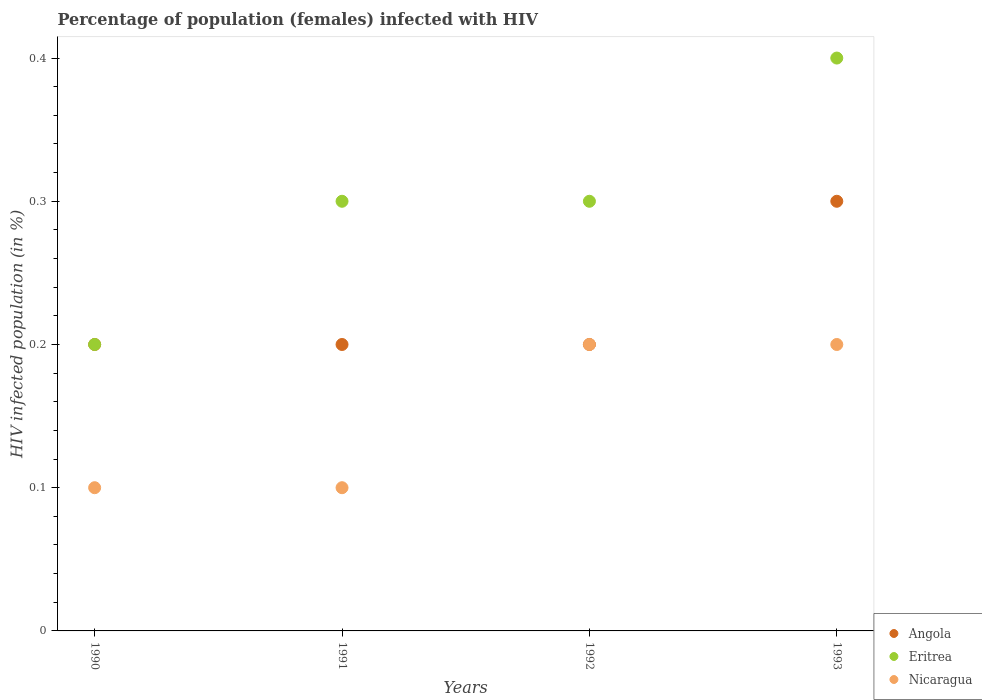How many different coloured dotlines are there?
Make the answer very short. 3. What is the percentage of HIV infected female population in Eritrea in 1991?
Give a very brief answer. 0.3. In which year was the percentage of HIV infected female population in Angola maximum?
Give a very brief answer. 1993. In which year was the percentage of HIV infected female population in Angola minimum?
Keep it short and to the point. 1990. What is the total percentage of HIV infected female population in Nicaragua in the graph?
Offer a terse response. 0.6. What is the difference between the percentage of HIV infected female population in Angola in 1990 and that in 1991?
Make the answer very short. 0. What is the difference between the percentage of HIV infected female population in Angola in 1992 and the percentage of HIV infected female population in Eritrea in 1990?
Ensure brevity in your answer.  0. What is the average percentage of HIV infected female population in Eritrea per year?
Your answer should be compact. 0.3. In the year 1991, what is the difference between the percentage of HIV infected female population in Nicaragua and percentage of HIV infected female population in Eritrea?
Ensure brevity in your answer.  -0.2. Is the difference between the percentage of HIV infected female population in Nicaragua in 1990 and 1991 greater than the difference between the percentage of HIV infected female population in Eritrea in 1990 and 1991?
Provide a succinct answer. Yes. What is the difference between the highest and the second highest percentage of HIV infected female population in Eritrea?
Your response must be concise. 0.1. What is the difference between the highest and the lowest percentage of HIV infected female population in Nicaragua?
Your answer should be very brief. 0.1. Is it the case that in every year, the sum of the percentage of HIV infected female population in Eritrea and percentage of HIV infected female population in Nicaragua  is greater than the percentage of HIV infected female population in Angola?
Offer a terse response. Yes. How many dotlines are there?
Ensure brevity in your answer.  3. What is the difference between two consecutive major ticks on the Y-axis?
Ensure brevity in your answer.  0.1. Are the values on the major ticks of Y-axis written in scientific E-notation?
Ensure brevity in your answer.  No. Does the graph contain grids?
Ensure brevity in your answer.  No. Where does the legend appear in the graph?
Offer a very short reply. Bottom right. How are the legend labels stacked?
Give a very brief answer. Vertical. What is the title of the graph?
Offer a terse response. Percentage of population (females) infected with HIV. Does "Malta" appear as one of the legend labels in the graph?
Make the answer very short. No. What is the label or title of the X-axis?
Give a very brief answer. Years. What is the label or title of the Y-axis?
Provide a succinct answer. HIV infected population (in %). What is the HIV infected population (in %) of Eritrea in 1990?
Ensure brevity in your answer.  0.2. What is the HIV infected population (in %) in Nicaragua in 1990?
Make the answer very short. 0.1. What is the HIV infected population (in %) of Angola in 1991?
Give a very brief answer. 0.2. What is the HIV infected population (in %) in Angola in 1992?
Provide a succinct answer. 0.2. What is the HIV infected population (in %) of Eritrea in 1992?
Your response must be concise. 0.3. What is the HIV infected population (in %) in Nicaragua in 1992?
Give a very brief answer. 0.2. What is the HIV infected population (in %) in Eritrea in 1993?
Offer a terse response. 0.4. What is the HIV infected population (in %) of Nicaragua in 1993?
Offer a terse response. 0.2. Across all years, what is the maximum HIV infected population (in %) of Angola?
Your answer should be compact. 0.3. Across all years, what is the minimum HIV infected population (in %) of Eritrea?
Keep it short and to the point. 0.2. What is the total HIV infected population (in %) of Eritrea in the graph?
Offer a very short reply. 1.2. What is the difference between the HIV infected population (in %) of Angola in 1990 and that in 1991?
Keep it short and to the point. 0. What is the difference between the HIV infected population (in %) in Nicaragua in 1990 and that in 1991?
Give a very brief answer. 0. What is the difference between the HIV infected population (in %) in Nicaragua in 1990 and that in 1993?
Provide a succinct answer. -0.1. What is the difference between the HIV infected population (in %) in Eritrea in 1991 and that in 1992?
Your answer should be compact. 0. What is the difference between the HIV infected population (in %) in Angola in 1991 and that in 1993?
Your answer should be very brief. -0.1. What is the difference between the HIV infected population (in %) in Nicaragua in 1992 and that in 1993?
Your answer should be very brief. 0. What is the difference between the HIV infected population (in %) of Eritrea in 1990 and the HIV infected population (in %) of Nicaragua in 1992?
Give a very brief answer. 0. What is the difference between the HIV infected population (in %) of Angola in 1990 and the HIV infected population (in %) of Eritrea in 1993?
Your answer should be very brief. -0.2. What is the difference between the HIV infected population (in %) of Angola in 1990 and the HIV infected population (in %) of Nicaragua in 1993?
Offer a terse response. 0. What is the difference between the HIV infected population (in %) of Eritrea in 1991 and the HIV infected population (in %) of Nicaragua in 1992?
Provide a succinct answer. 0.1. What is the difference between the HIV infected population (in %) of Angola in 1991 and the HIV infected population (in %) of Eritrea in 1993?
Give a very brief answer. -0.2. What is the difference between the HIV infected population (in %) of Angola in 1992 and the HIV infected population (in %) of Eritrea in 1993?
Ensure brevity in your answer.  -0.2. What is the average HIV infected population (in %) of Angola per year?
Give a very brief answer. 0.23. In the year 1990, what is the difference between the HIV infected population (in %) in Angola and HIV infected population (in %) in Eritrea?
Make the answer very short. 0. In the year 1990, what is the difference between the HIV infected population (in %) in Eritrea and HIV infected population (in %) in Nicaragua?
Your answer should be compact. 0.1. In the year 1991, what is the difference between the HIV infected population (in %) of Angola and HIV infected population (in %) of Eritrea?
Ensure brevity in your answer.  -0.1. In the year 1991, what is the difference between the HIV infected population (in %) of Angola and HIV infected population (in %) of Nicaragua?
Your answer should be very brief. 0.1. In the year 1991, what is the difference between the HIV infected population (in %) in Eritrea and HIV infected population (in %) in Nicaragua?
Your answer should be very brief. 0.2. In the year 1993, what is the difference between the HIV infected population (in %) in Angola and HIV infected population (in %) in Eritrea?
Offer a very short reply. -0.1. In the year 1993, what is the difference between the HIV infected population (in %) of Eritrea and HIV infected population (in %) of Nicaragua?
Ensure brevity in your answer.  0.2. What is the ratio of the HIV infected population (in %) of Nicaragua in 1990 to that in 1991?
Keep it short and to the point. 1. What is the ratio of the HIV infected population (in %) in Angola in 1990 to that in 1992?
Provide a short and direct response. 1. What is the ratio of the HIV infected population (in %) in Eritrea in 1990 to that in 1992?
Provide a short and direct response. 0.67. What is the ratio of the HIV infected population (in %) in Angola in 1991 to that in 1992?
Offer a very short reply. 1. What is the ratio of the HIV infected population (in %) in Nicaragua in 1991 to that in 1992?
Your answer should be very brief. 0.5. What is the ratio of the HIV infected population (in %) in Angola in 1991 to that in 1993?
Your answer should be very brief. 0.67. What is the ratio of the HIV infected population (in %) of Eritrea in 1991 to that in 1993?
Give a very brief answer. 0.75. What is the difference between the highest and the second highest HIV infected population (in %) of Angola?
Your answer should be very brief. 0.1. What is the difference between the highest and the second highest HIV infected population (in %) in Nicaragua?
Give a very brief answer. 0. What is the difference between the highest and the lowest HIV infected population (in %) in Angola?
Ensure brevity in your answer.  0.1. What is the difference between the highest and the lowest HIV infected population (in %) of Eritrea?
Ensure brevity in your answer.  0.2. 